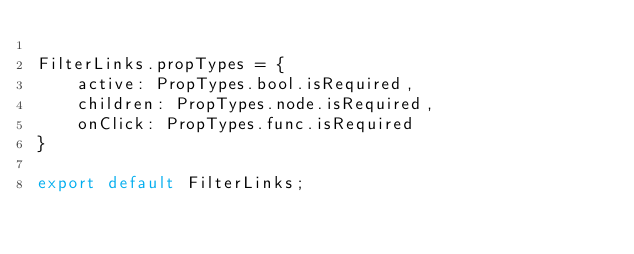Convert code to text. <code><loc_0><loc_0><loc_500><loc_500><_JavaScript_>
FilterLinks.propTypes = {
    active: PropTypes.bool.isRequired,
    children: PropTypes.node.isRequired,
    onClick: PropTypes.func.isRequired
}

export default FilterLinks;</code> 